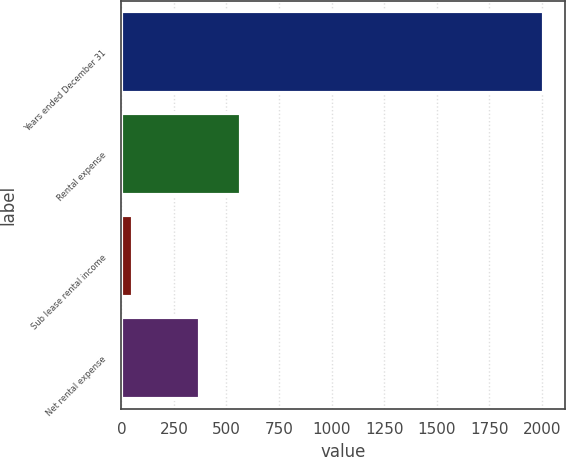Convert chart to OTSL. <chart><loc_0><loc_0><loc_500><loc_500><bar_chart><fcel>Years ended December 31<fcel>Rental expense<fcel>Sub lease rental income<fcel>Net rental expense<nl><fcel>2010<fcel>567.3<fcel>57<fcel>372<nl></chart> 